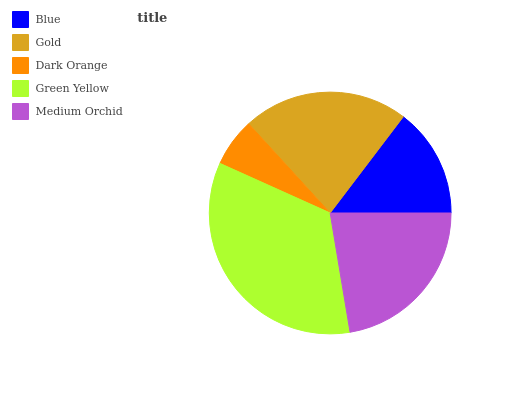Is Dark Orange the minimum?
Answer yes or no. Yes. Is Green Yellow the maximum?
Answer yes or no. Yes. Is Gold the minimum?
Answer yes or no. No. Is Gold the maximum?
Answer yes or no. No. Is Gold greater than Blue?
Answer yes or no. Yes. Is Blue less than Gold?
Answer yes or no. Yes. Is Blue greater than Gold?
Answer yes or no. No. Is Gold less than Blue?
Answer yes or no. No. Is Gold the high median?
Answer yes or no. Yes. Is Gold the low median?
Answer yes or no. Yes. Is Medium Orchid the high median?
Answer yes or no. No. Is Blue the low median?
Answer yes or no. No. 